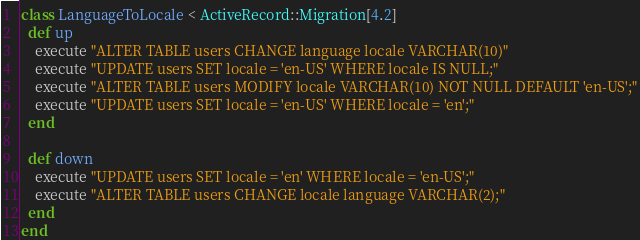<code> <loc_0><loc_0><loc_500><loc_500><_Ruby_>class LanguageToLocale < ActiveRecord::Migration[4.2]
  def up
    execute "ALTER TABLE users CHANGE language locale VARCHAR(10)"
    execute "UPDATE users SET locale = 'en-US' WHERE locale IS NULL;"
    execute "ALTER TABLE users MODIFY locale VARCHAR(10) NOT NULL DEFAULT 'en-US';"
    execute "UPDATE users SET locale = 'en-US' WHERE locale = 'en';"
  end

  def down
    execute "UPDATE users SET locale = 'en' WHERE locale = 'en-US';"
    execute "ALTER TABLE users CHANGE locale language VARCHAR(2);"
  end
end
</code> 